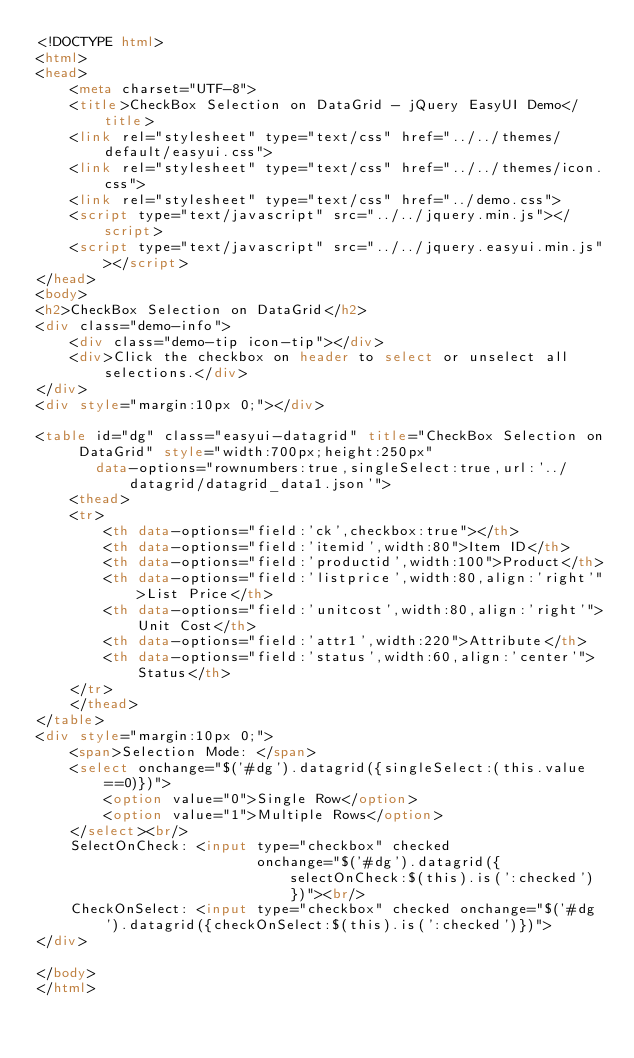<code> <loc_0><loc_0><loc_500><loc_500><_HTML_><!DOCTYPE html>
<html>
<head>
    <meta charset="UTF-8">
    <title>CheckBox Selection on DataGrid - jQuery EasyUI Demo</title>
    <link rel="stylesheet" type="text/css" href="../../themes/default/easyui.css">
    <link rel="stylesheet" type="text/css" href="../../themes/icon.css">
    <link rel="stylesheet" type="text/css" href="../demo.css">
    <script type="text/javascript" src="../../jquery.min.js"></script>
    <script type="text/javascript" src="../../jquery.easyui.min.js"></script>
</head>
<body>
<h2>CheckBox Selection on DataGrid</h2>
<div class="demo-info">
    <div class="demo-tip icon-tip"></div>
    <div>Click the checkbox on header to select or unselect all selections.</div>
</div>
<div style="margin:10px 0;"></div>

<table id="dg" class="easyui-datagrid" title="CheckBox Selection on DataGrid" style="width:700px;height:250px"
       data-options="rownumbers:true,singleSelect:true,url:'../datagrid/datagrid_data1.json'">
    <thead>
    <tr>
        <th data-options="field:'ck',checkbox:true"></th>
        <th data-options="field:'itemid',width:80">Item ID</th>
        <th data-options="field:'productid',width:100">Product</th>
        <th data-options="field:'listprice',width:80,align:'right'">List Price</th>
        <th data-options="field:'unitcost',width:80,align:'right'">Unit Cost</th>
        <th data-options="field:'attr1',width:220">Attribute</th>
        <th data-options="field:'status',width:60,align:'center'">Status</th>
    </tr>
    </thead>
</table>
<div style="margin:10px 0;">
    <span>Selection Mode: </span>
    <select onchange="$('#dg').datagrid({singleSelect:(this.value==0)})">
        <option value="0">Single Row</option>
        <option value="1">Multiple Rows</option>
    </select><br/>
    SelectOnCheck: <input type="checkbox" checked
                          onchange="$('#dg').datagrid({selectOnCheck:$(this).is(':checked')})"><br/>
    CheckOnSelect: <input type="checkbox" checked onchange="$('#dg').datagrid({checkOnSelect:$(this).is(':checked')})">
</div>

</body>
</html></code> 